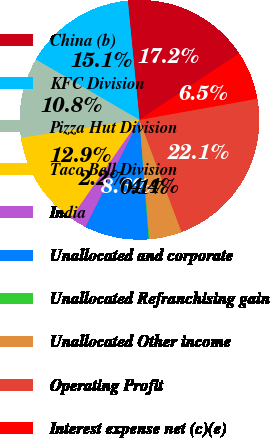<chart> <loc_0><loc_0><loc_500><loc_500><pie_chart><fcel>China (b)<fcel>KFC Division<fcel>Pizza Hut Division<fcel>Taco Bell Division<fcel>India<fcel>Unallocated and corporate<fcel>Unallocated Refranchising gain<fcel>Unallocated Other income<fcel>Operating Profit<fcel>Interest expense net (c)(e)<nl><fcel>17.2%<fcel>15.06%<fcel>10.79%<fcel>12.93%<fcel>2.25%<fcel>8.65%<fcel>0.11%<fcel>4.38%<fcel>22.11%<fcel>6.52%<nl></chart> 